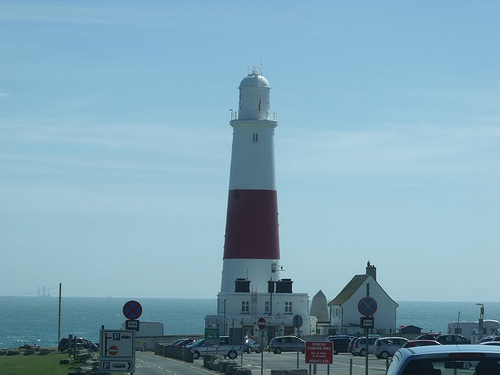<image>
Is there a sign board under the sky? Yes. The sign board is positioned underneath the sky, with the sky above it in the vertical space. Where is the sky in relation to the light house? Is it behind the light house? Yes. From this viewpoint, the sky is positioned behind the light house, with the light house partially or fully occluding the sky. 